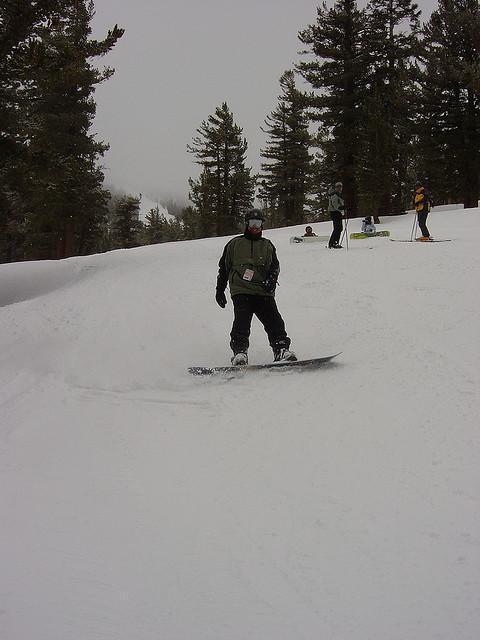How many people are in the picture?
Give a very brief answer. 1. 